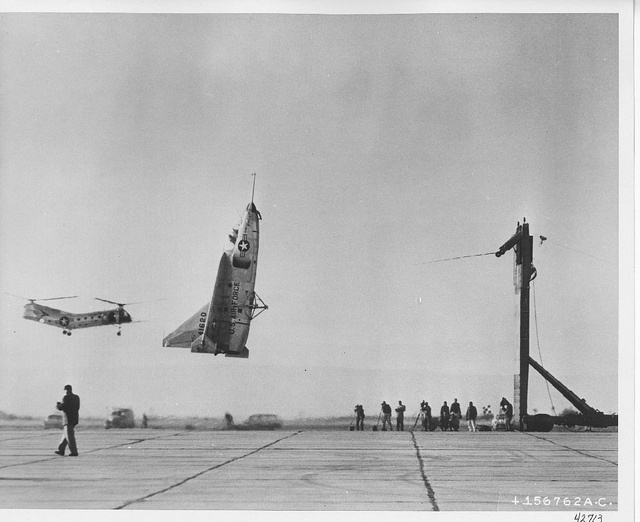Describe the objects in this image and their specific colors. I can see airplane in white, gray, black, darkgray, and lightgray tones, airplane in white, gray, darkgray, black, and lightgray tones, people in white, black, gray, darkgray, and lightgray tones, truck in white, gray, darkgray, black, and lightgray tones, and people in white, black, gray, darkgray, and lightgray tones in this image. 